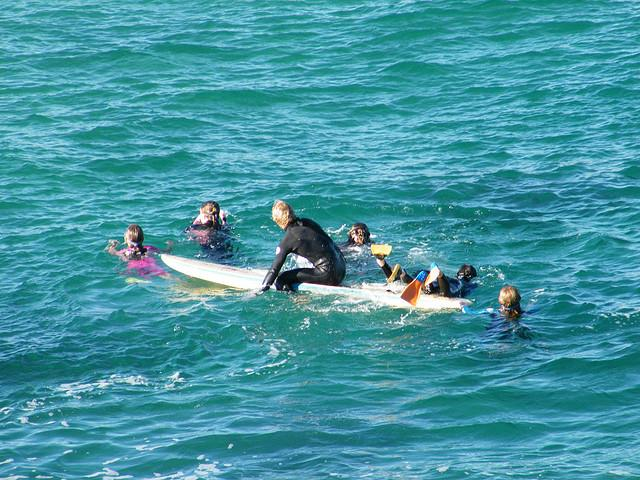What is the orange object on the woman's foot? Please explain your reasoning. swimfins. I see the swimfins on them. 